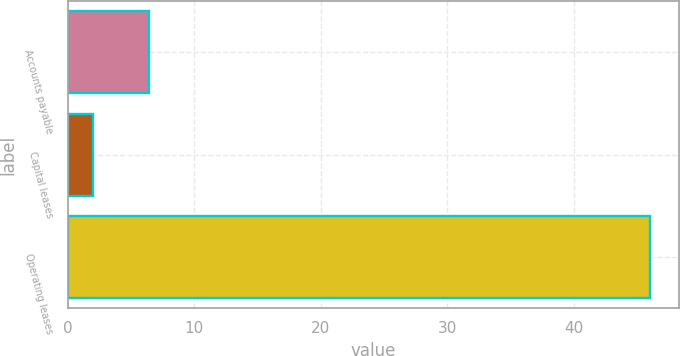<chart> <loc_0><loc_0><loc_500><loc_500><bar_chart><fcel>Accounts payable<fcel>Capital leases<fcel>Operating leases<nl><fcel>6.4<fcel>2<fcel>46<nl></chart> 